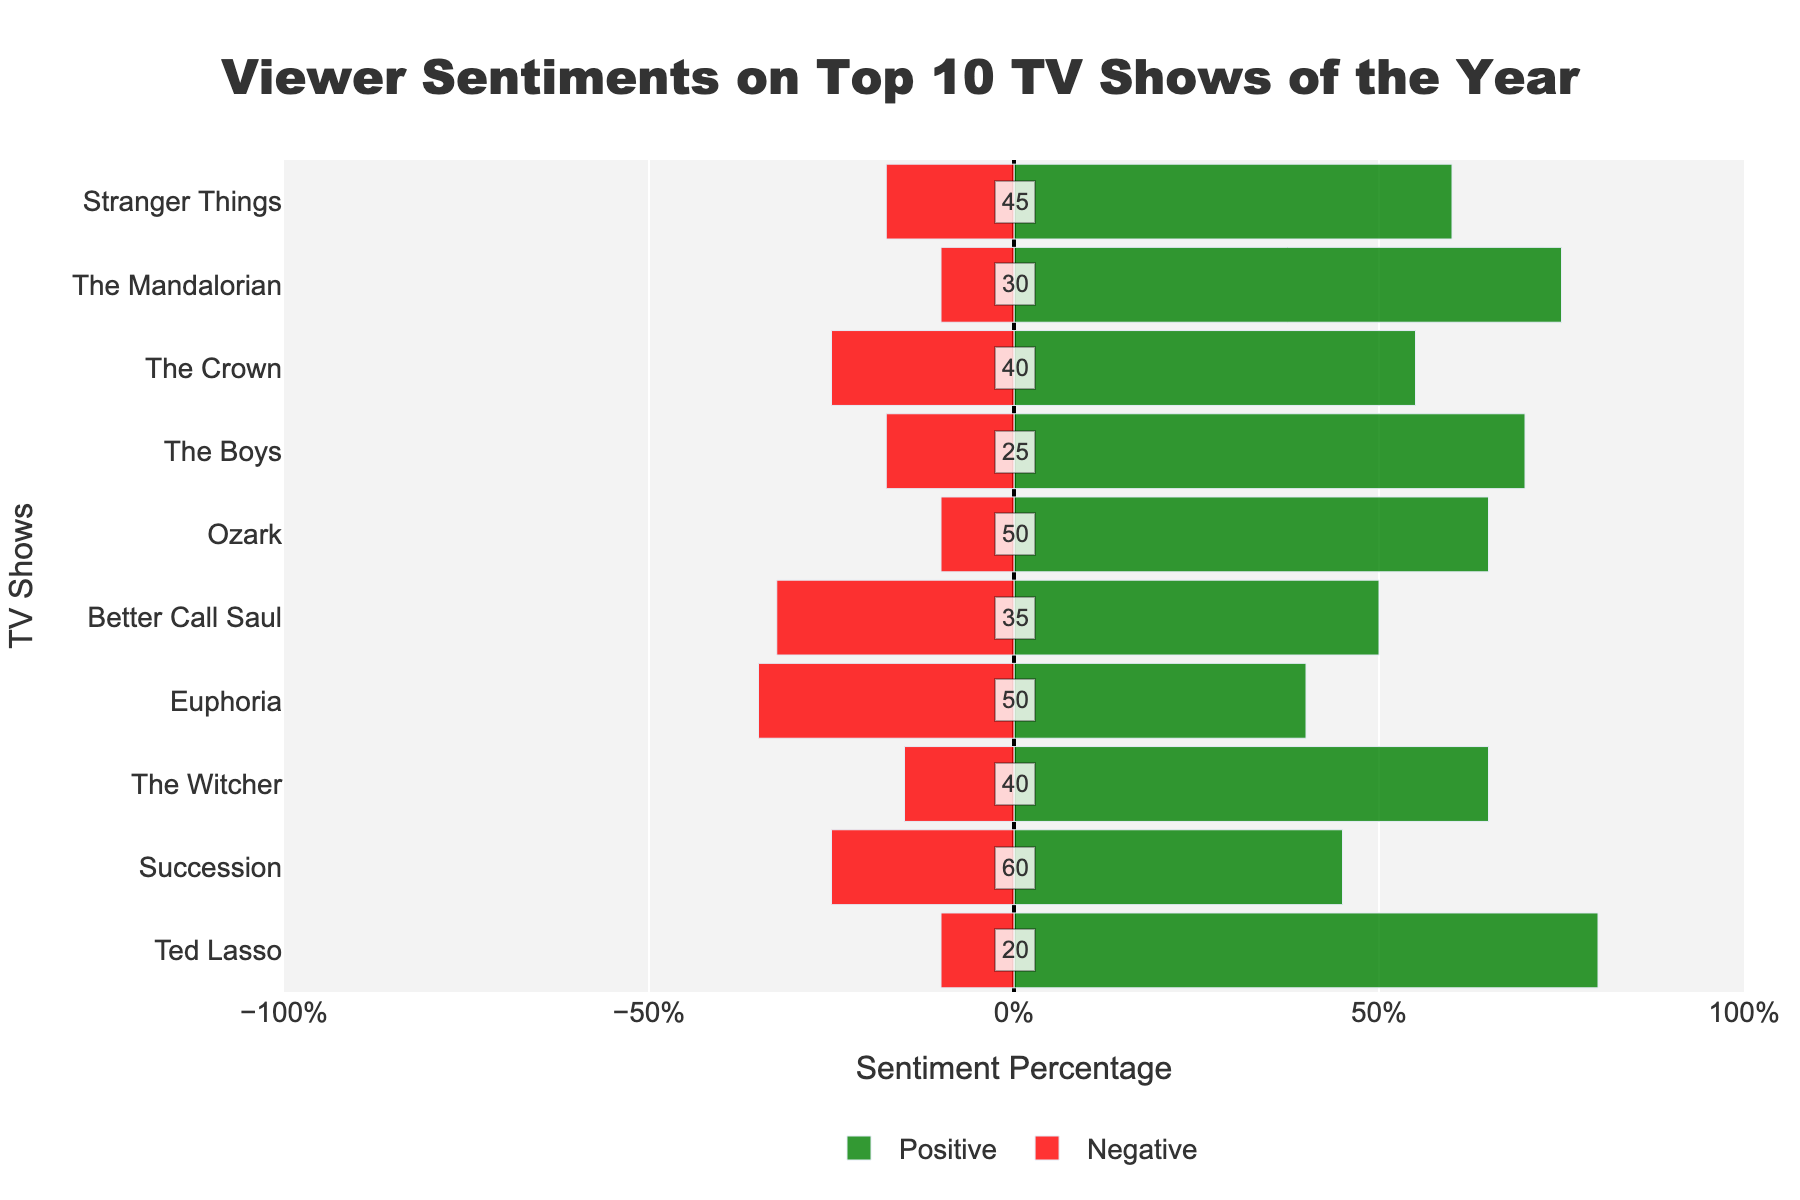Which TV show has the highest percentage of negative sentiment? To determine this, observe the red bars representing negative sentiment and locate the bar that extends the farthest to the left. The show with the longest red bar has the highest percentage of negative sentiment.
Answer: Euphoria Which TV show has the highest percentage of positive sentiment? Look at the green bars representing positive sentiment and identify which one extends the farthest to the right. That TV show has the highest percentage of positive sentiment.
Answer: Ted Lasso What is the net sentiment (positive minus negative) for 'Stranger Things'? For 'Stranger Things', find the positive sentiment percentage and subtract the negative sentiment percentage. The positive sentiment is 60% and the negative sentiment is 17.5%, so the net sentiment is 60% - 17.5% = 42.5%.
Answer: 42.5% Which TV show has the smallest neutral sentiment? Neutral sentiment is shown as text annotations in the center of each bar. Compare all text annotations and identify the smallest numerical value.
Answer: Ted Lasso Compare the positive sentiment percentages of 'The Mandalorian' and 'The Crown'. Which one is higher and by how much? Observe the green bars of both shows. 'The Mandalorian' has 75% positive sentiment and 'The Crown' has 55%, so the difference is 75% - 55% = 20%.
Answer: The Mandalorian by 20% Which show from the given dataset has the most balanced sentiment distribution (least difference between positive and negative sentiments)? Calculate the absolute difference between positive and negative sentiment percentages for each show and identify the smallest difference.
Answer: The Witcher What is the combined percentage of neutral sentiment for 'Ozark' and 'Succession'? Neutral sentiment is indicated by numbers in each bar. Sum the neutral sentiment values for 'Ozark' (50) and 'Succession' (60).
Answer: 110% How does the negative sentiment of 'Better Call Saul' compare to that of 'Stranger Things'? Compare the lengths of the red bars for both shows. 'Better Call Saul' has a negative sentiment of 32.5%, while 'Stranger Things' has 17.5%. Thus, 'Better Call Saul' has a higher negative sentiment by 32.5% - 17.5% = 15%.
Answer: Better Call Saul by 15% Which TV shows have more positive sentiment than 'The Boys'? Identify TV shows where the green bar percentage is higher than that of 'The Boys' (70%). These shows are 'The Mandalorian' (75%), 'Ted Lasso' (80%), and 'Ozark' (65%).
Answer: The Mandalorian, Ted Lasso, Ozark What is the proportion of positive, neutral, and negative sentiments for 'Succession'? Calculate the percentages of positive (30%), neutral (40%), and negative (50%) sentiments for 'Succession' and present them in a proportion format.
Answer: 30% positive, 40% neutral, 50% negative 